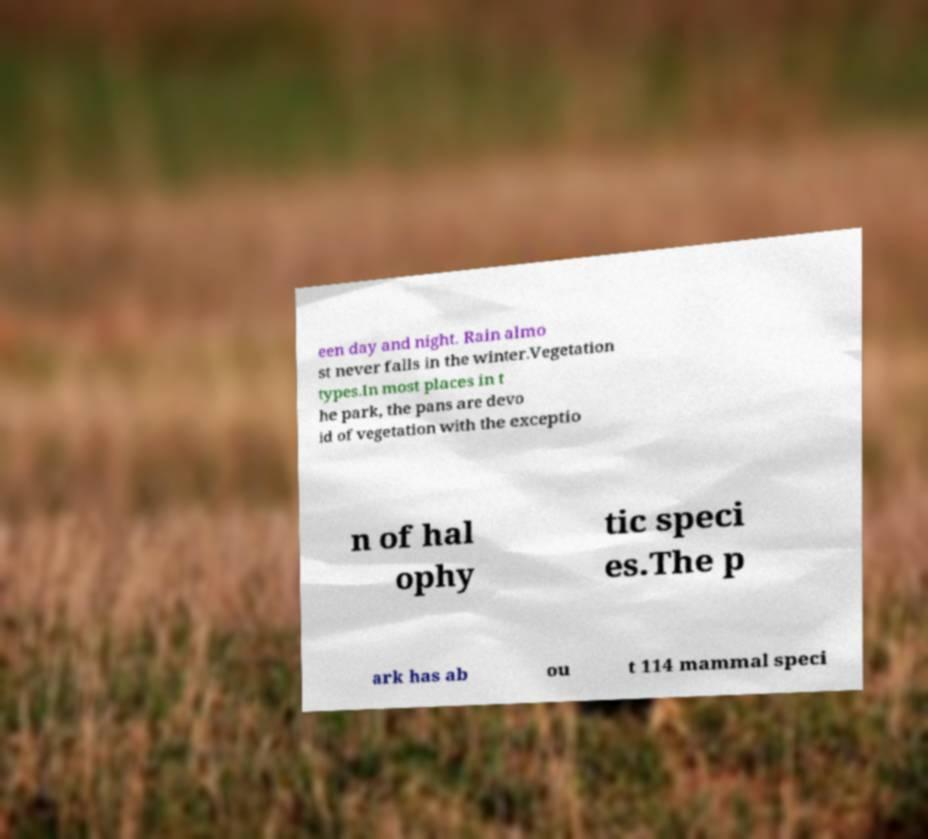Can you accurately transcribe the text from the provided image for me? een day and night. Rain almo st never falls in the winter.Vegetation types.In most places in t he park, the pans are devo id of vegetation with the exceptio n of hal ophy tic speci es.The p ark has ab ou t 114 mammal speci 